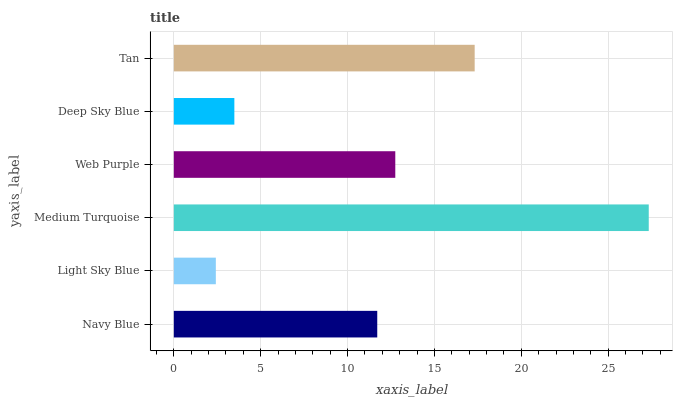Is Light Sky Blue the minimum?
Answer yes or no. Yes. Is Medium Turquoise the maximum?
Answer yes or no. Yes. Is Medium Turquoise the minimum?
Answer yes or no. No. Is Light Sky Blue the maximum?
Answer yes or no. No. Is Medium Turquoise greater than Light Sky Blue?
Answer yes or no. Yes. Is Light Sky Blue less than Medium Turquoise?
Answer yes or no. Yes. Is Light Sky Blue greater than Medium Turquoise?
Answer yes or no. No. Is Medium Turquoise less than Light Sky Blue?
Answer yes or no. No. Is Web Purple the high median?
Answer yes or no. Yes. Is Navy Blue the low median?
Answer yes or no. Yes. Is Light Sky Blue the high median?
Answer yes or no. No. Is Light Sky Blue the low median?
Answer yes or no. No. 